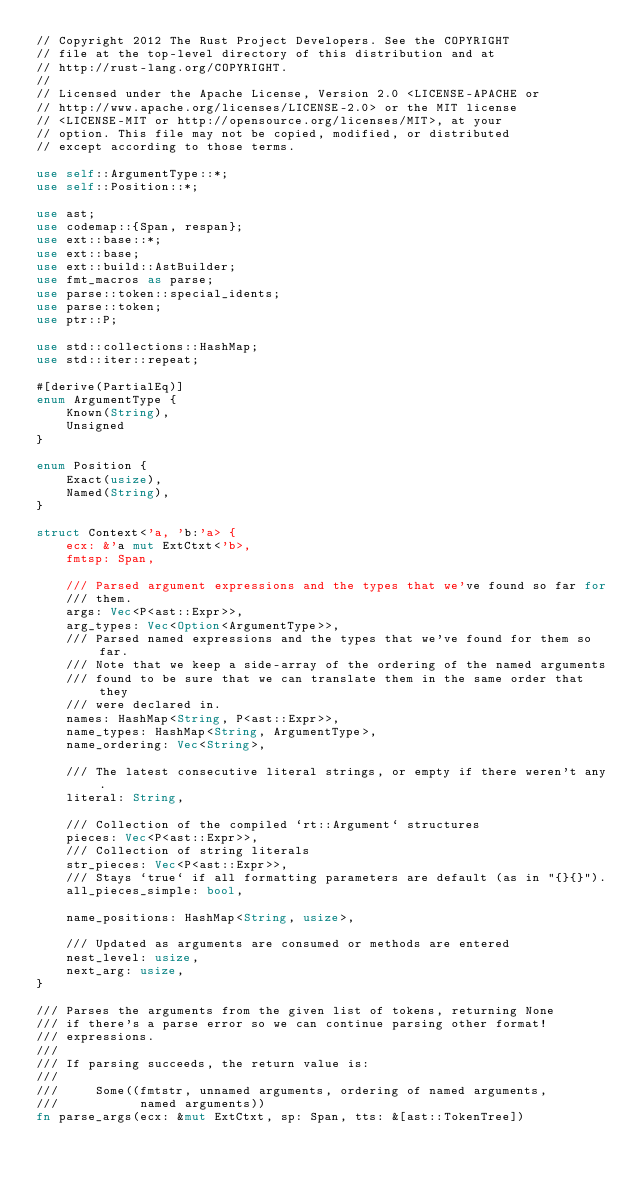Convert code to text. <code><loc_0><loc_0><loc_500><loc_500><_Rust_>// Copyright 2012 The Rust Project Developers. See the COPYRIGHT
// file at the top-level directory of this distribution and at
// http://rust-lang.org/COPYRIGHT.
//
// Licensed under the Apache License, Version 2.0 <LICENSE-APACHE or
// http://www.apache.org/licenses/LICENSE-2.0> or the MIT license
// <LICENSE-MIT or http://opensource.org/licenses/MIT>, at your
// option. This file may not be copied, modified, or distributed
// except according to those terms.

use self::ArgumentType::*;
use self::Position::*;

use ast;
use codemap::{Span, respan};
use ext::base::*;
use ext::base;
use ext::build::AstBuilder;
use fmt_macros as parse;
use parse::token::special_idents;
use parse::token;
use ptr::P;

use std::collections::HashMap;
use std::iter::repeat;

#[derive(PartialEq)]
enum ArgumentType {
    Known(String),
    Unsigned
}

enum Position {
    Exact(usize),
    Named(String),
}

struct Context<'a, 'b:'a> {
    ecx: &'a mut ExtCtxt<'b>,
    fmtsp: Span,

    /// Parsed argument expressions and the types that we've found so far for
    /// them.
    args: Vec<P<ast::Expr>>,
    arg_types: Vec<Option<ArgumentType>>,
    /// Parsed named expressions and the types that we've found for them so far.
    /// Note that we keep a side-array of the ordering of the named arguments
    /// found to be sure that we can translate them in the same order that they
    /// were declared in.
    names: HashMap<String, P<ast::Expr>>,
    name_types: HashMap<String, ArgumentType>,
    name_ordering: Vec<String>,

    /// The latest consecutive literal strings, or empty if there weren't any.
    literal: String,

    /// Collection of the compiled `rt::Argument` structures
    pieces: Vec<P<ast::Expr>>,
    /// Collection of string literals
    str_pieces: Vec<P<ast::Expr>>,
    /// Stays `true` if all formatting parameters are default (as in "{}{}").
    all_pieces_simple: bool,

    name_positions: HashMap<String, usize>,

    /// Updated as arguments are consumed or methods are entered
    nest_level: usize,
    next_arg: usize,
}

/// Parses the arguments from the given list of tokens, returning None
/// if there's a parse error so we can continue parsing other format!
/// expressions.
///
/// If parsing succeeds, the return value is:
///
///     Some((fmtstr, unnamed arguments, ordering of named arguments,
///           named arguments))
fn parse_args(ecx: &mut ExtCtxt, sp: Span, tts: &[ast::TokenTree])</code> 